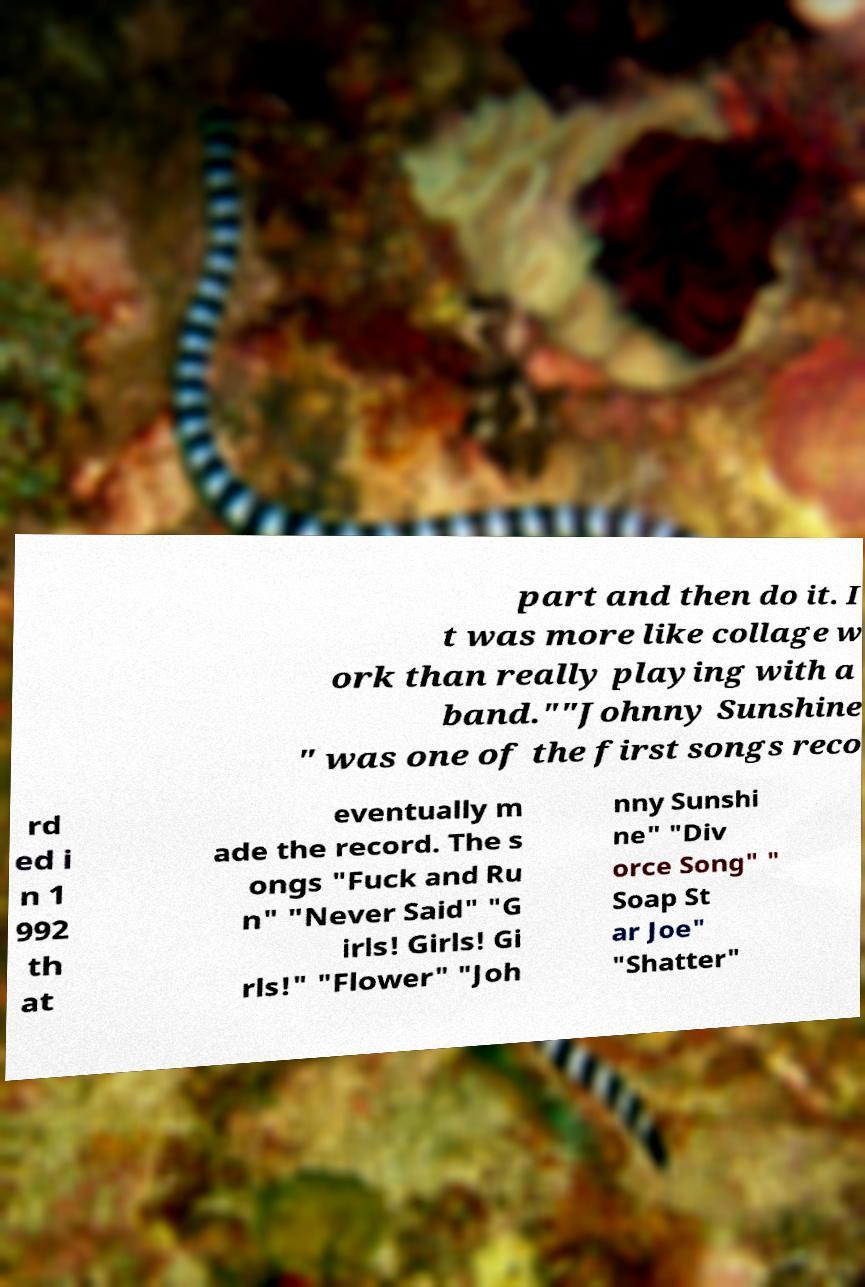I need the written content from this picture converted into text. Can you do that? part and then do it. I t was more like collage w ork than really playing with a band.""Johnny Sunshine " was one of the first songs reco rd ed i n 1 992 th at eventually m ade the record. The s ongs "Fuck and Ru n" "Never Said" "G irls! Girls! Gi rls!" "Flower" "Joh nny Sunshi ne" "Div orce Song" " Soap St ar Joe" "Shatter" 